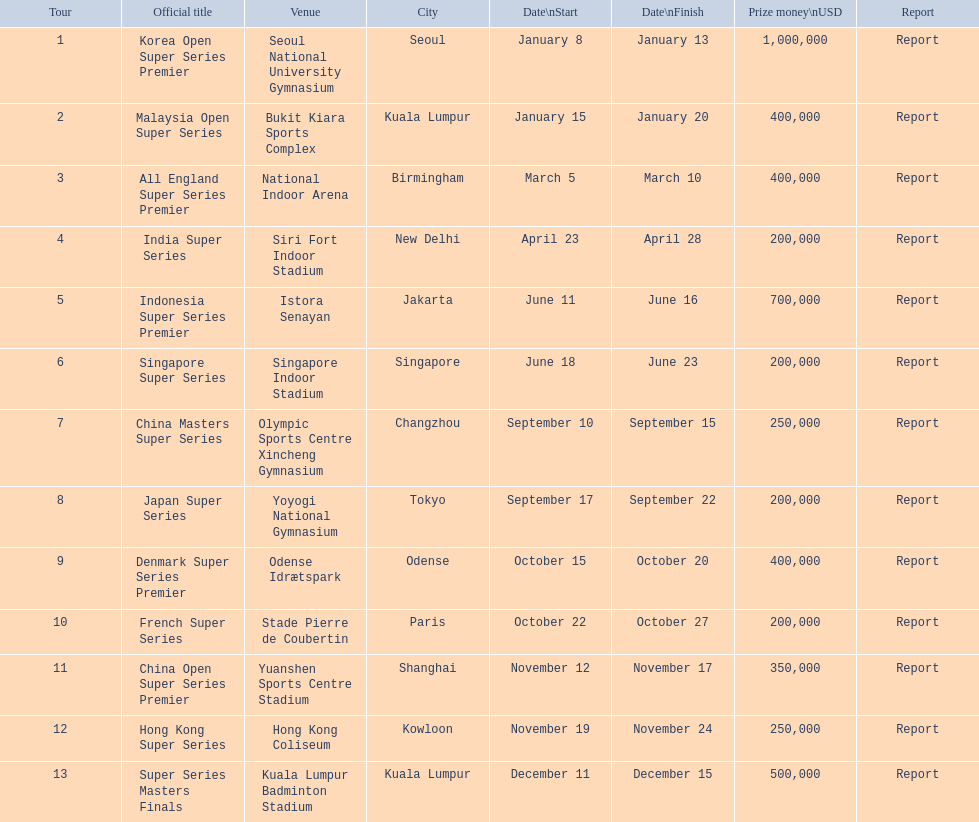Would you mind parsing the complete table? {'header': ['Tour', 'Official title', 'Venue', 'City', 'Date\\nStart', 'Date\\nFinish', 'Prize money\\nUSD', 'Report'], 'rows': [['1', 'Korea Open Super Series Premier', 'Seoul National University Gymnasium', 'Seoul', 'January 8', 'January 13', '1,000,000', 'Report'], ['2', 'Malaysia Open Super Series', 'Bukit Kiara Sports Complex', 'Kuala Lumpur', 'January 15', 'January 20', '400,000', 'Report'], ['3', 'All England Super Series Premier', 'National Indoor Arena', 'Birmingham', 'March 5', 'March 10', '400,000', 'Report'], ['4', 'India Super Series', 'Siri Fort Indoor Stadium', 'New Delhi', 'April 23', 'April 28', '200,000', 'Report'], ['5', 'Indonesia Super Series Premier', 'Istora Senayan', 'Jakarta', 'June 11', 'June 16', '700,000', 'Report'], ['6', 'Singapore Super Series', 'Singapore Indoor Stadium', 'Singapore', 'June 18', 'June 23', '200,000', 'Report'], ['7', 'China Masters Super Series', 'Olympic Sports Centre Xincheng Gymnasium', 'Changzhou', 'September 10', 'September 15', '250,000', 'Report'], ['8', 'Japan Super Series', 'Yoyogi National Gymnasium', 'Tokyo', 'September 17', 'September 22', '200,000', 'Report'], ['9', 'Denmark Super Series Premier', 'Odense Idrætspark', 'Odense', 'October 15', 'October 20', '400,000', 'Report'], ['10', 'French Super Series', 'Stade Pierre de Coubertin', 'Paris', 'October 22', 'October 27', '200,000', 'Report'], ['11', 'China Open Super Series Premier', 'Yuanshen Sports Centre Stadium', 'Shanghai', 'November 12', 'November 17', '350,000', 'Report'], ['12', 'Hong Kong Super Series', 'Hong Kong Coliseum', 'Kowloon', 'November 19', 'November 24', '250,000', 'Report'], ['13', 'Super Series Masters Finals', 'Kuala Lumpur Badminton Stadium', 'Kuala Lumpur', 'December 11', 'December 15', '500,000', 'Report']]} Is the payout for the malaysia open super series more or less than the french super series? More. 